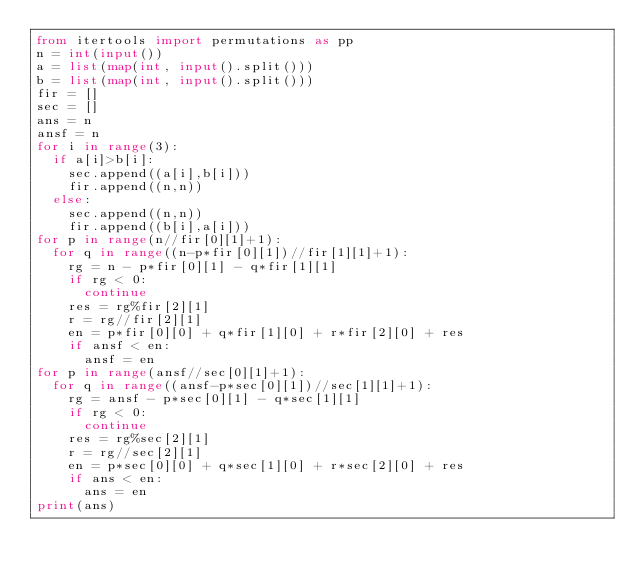Convert code to text. <code><loc_0><loc_0><loc_500><loc_500><_Python_>from itertools import permutations as pp
n = int(input())
a = list(map(int, input().split()))
b = list(map(int, input().split()))
fir = []
sec = []
ans = n
ansf = n
for i in range(3):
  if a[i]>b[i]:
    sec.append((a[i],b[i]))
    fir.append((n,n))
  else:
    sec.append((n,n))
    fir.append((b[i],a[i]))
for p in range(n//fir[0][1]+1):
  for q in range((n-p*fir[0][1])//fir[1][1]+1):
    rg = n - p*fir[0][1] - q*fir[1][1]
    if rg < 0:
      continue
    res = rg%fir[2][1]
    r = rg//fir[2][1]
    en = p*fir[0][0] + q*fir[1][0] + r*fir[2][0] + res
    if ansf < en:
      ansf = en
for p in range(ansf//sec[0][1]+1):
  for q in range((ansf-p*sec[0][1])//sec[1][1]+1):
    rg = ansf - p*sec[0][1] - q*sec[1][1]
    if rg < 0:
      continue
    res = rg%sec[2][1]
    r = rg//sec[2][1]
    en = p*sec[0][0] + q*sec[1][0] + r*sec[2][0] + res
    if ans < en:
      ans = en
print(ans)</code> 